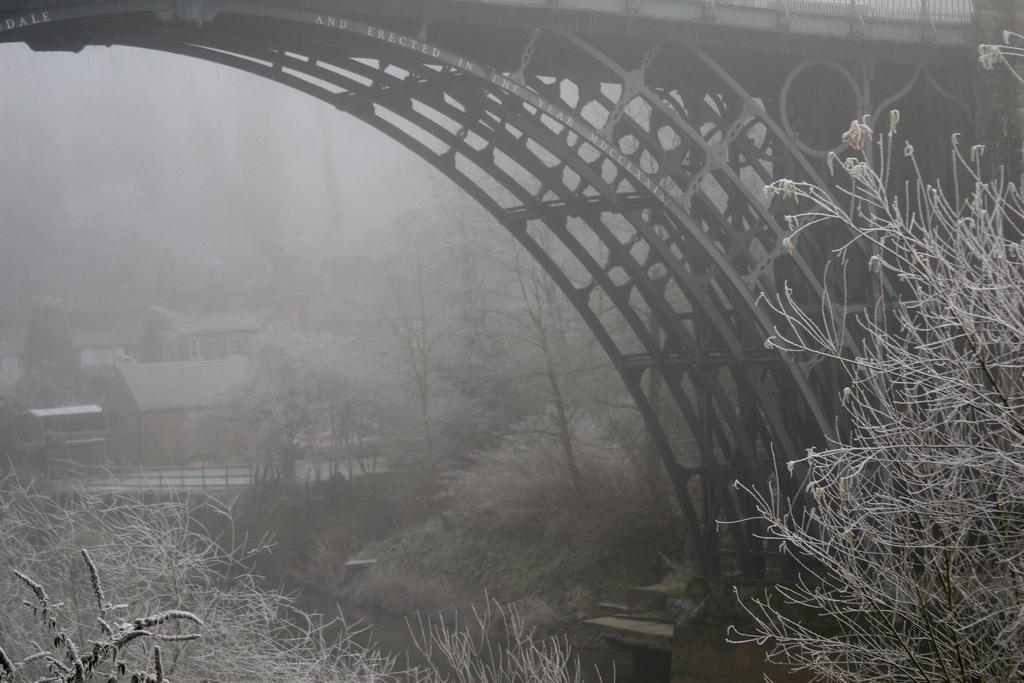How would you summarize this image in a sentence or two? In this picture there is the water at the bottom, there are trees on either side of this image. On the right side it looks like a bridge, in the background there are houses. 